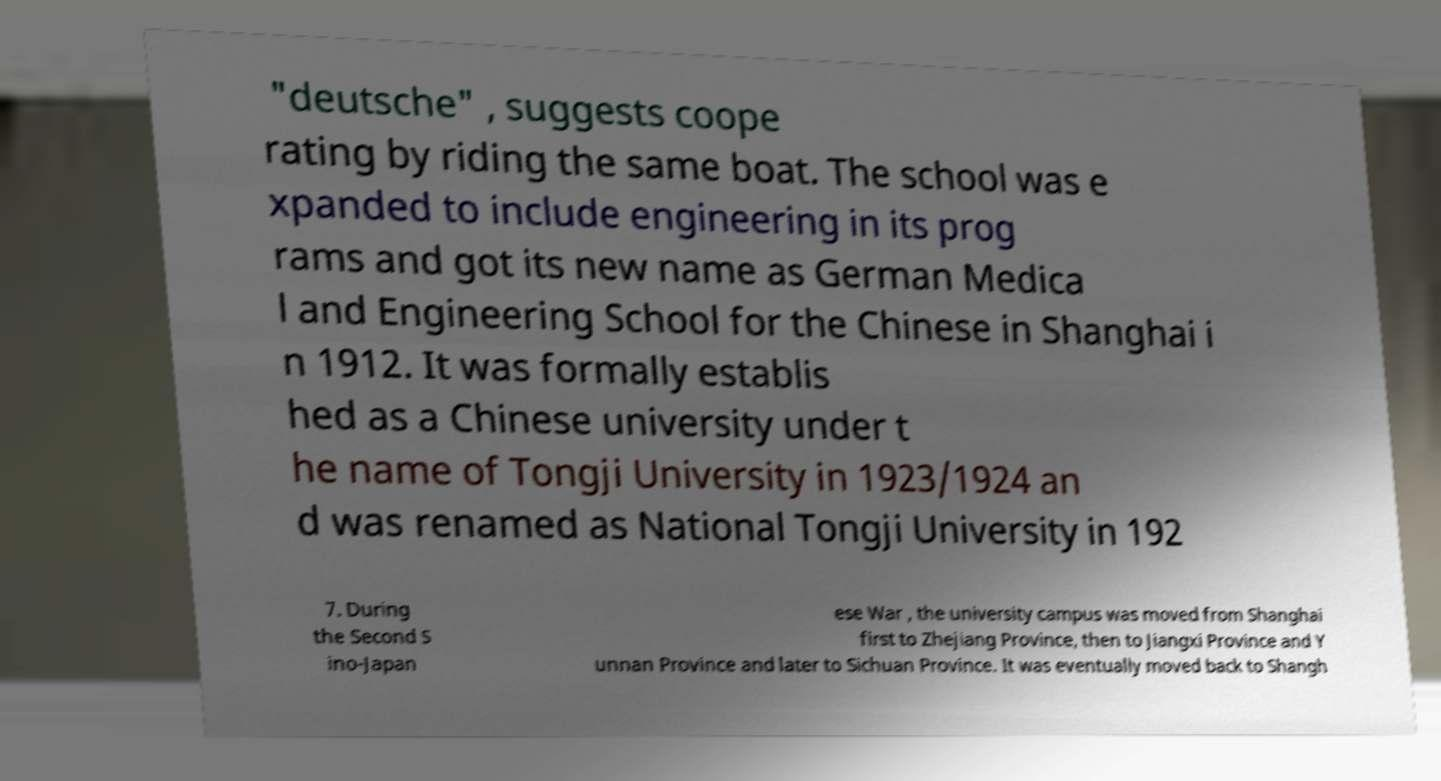Could you assist in decoding the text presented in this image and type it out clearly? "deutsche" , suggests coope rating by riding the same boat. The school was e xpanded to include engineering in its prog rams and got its new name as German Medica l and Engineering School for the Chinese in Shanghai i n 1912. It was formally establis hed as a Chinese university under t he name of Tongji University in 1923/1924 an d was renamed as National Tongji University in 192 7. During the Second S ino-Japan ese War , the university campus was moved from Shanghai first to Zhejiang Province, then to Jiangxi Province and Y unnan Province and later to Sichuan Province. It was eventually moved back to Shangh 